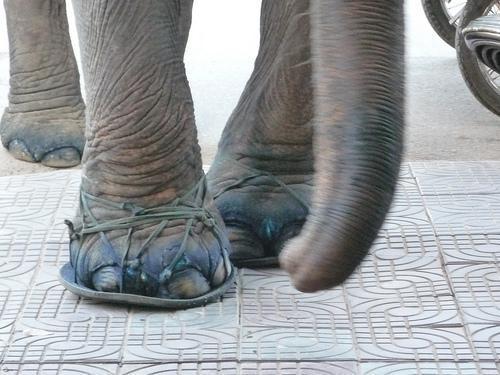How many legs are visible in the picture?
Give a very brief answer. 3. 